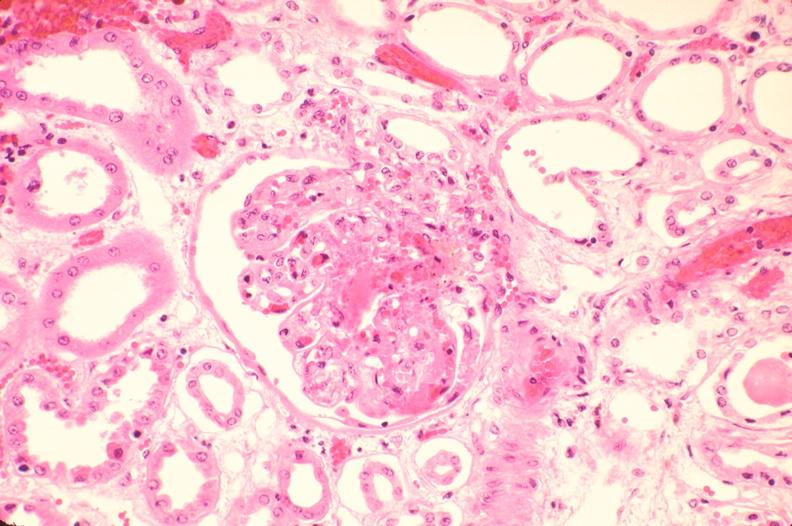where is this?
Answer the question using a single word or phrase. Urinary 